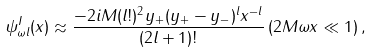<formula> <loc_0><loc_0><loc_500><loc_500>\psi _ { \omega l } ^ { I } ( x ) \approx \frac { - 2 i M ( l ! ) ^ { 2 } y _ { + } ( y _ { + } - y _ { - } ) ^ { l } x ^ { - l } } { ( 2 l + 1 ) ! } \, ( 2 M \omega x \ll 1 ) \, ,</formula> 